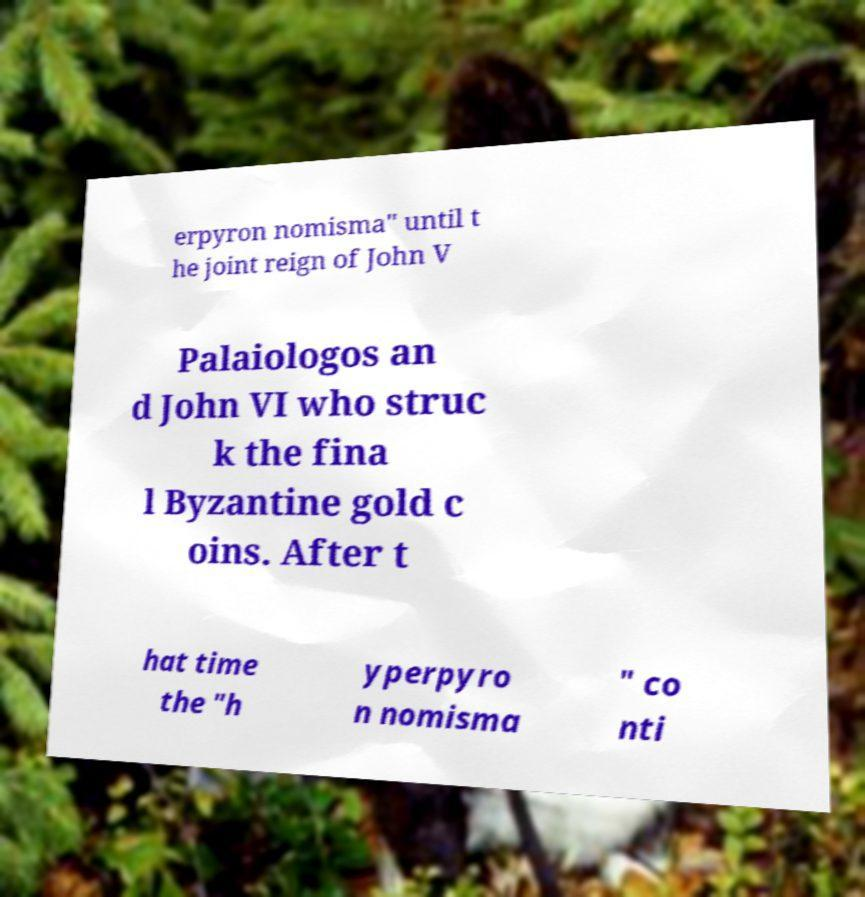For documentation purposes, I need the text within this image transcribed. Could you provide that? erpyron nomisma" until t he joint reign of John V Palaiologos an d John VI who struc k the fina l Byzantine gold c oins. After t hat time the "h yperpyro n nomisma " co nti 